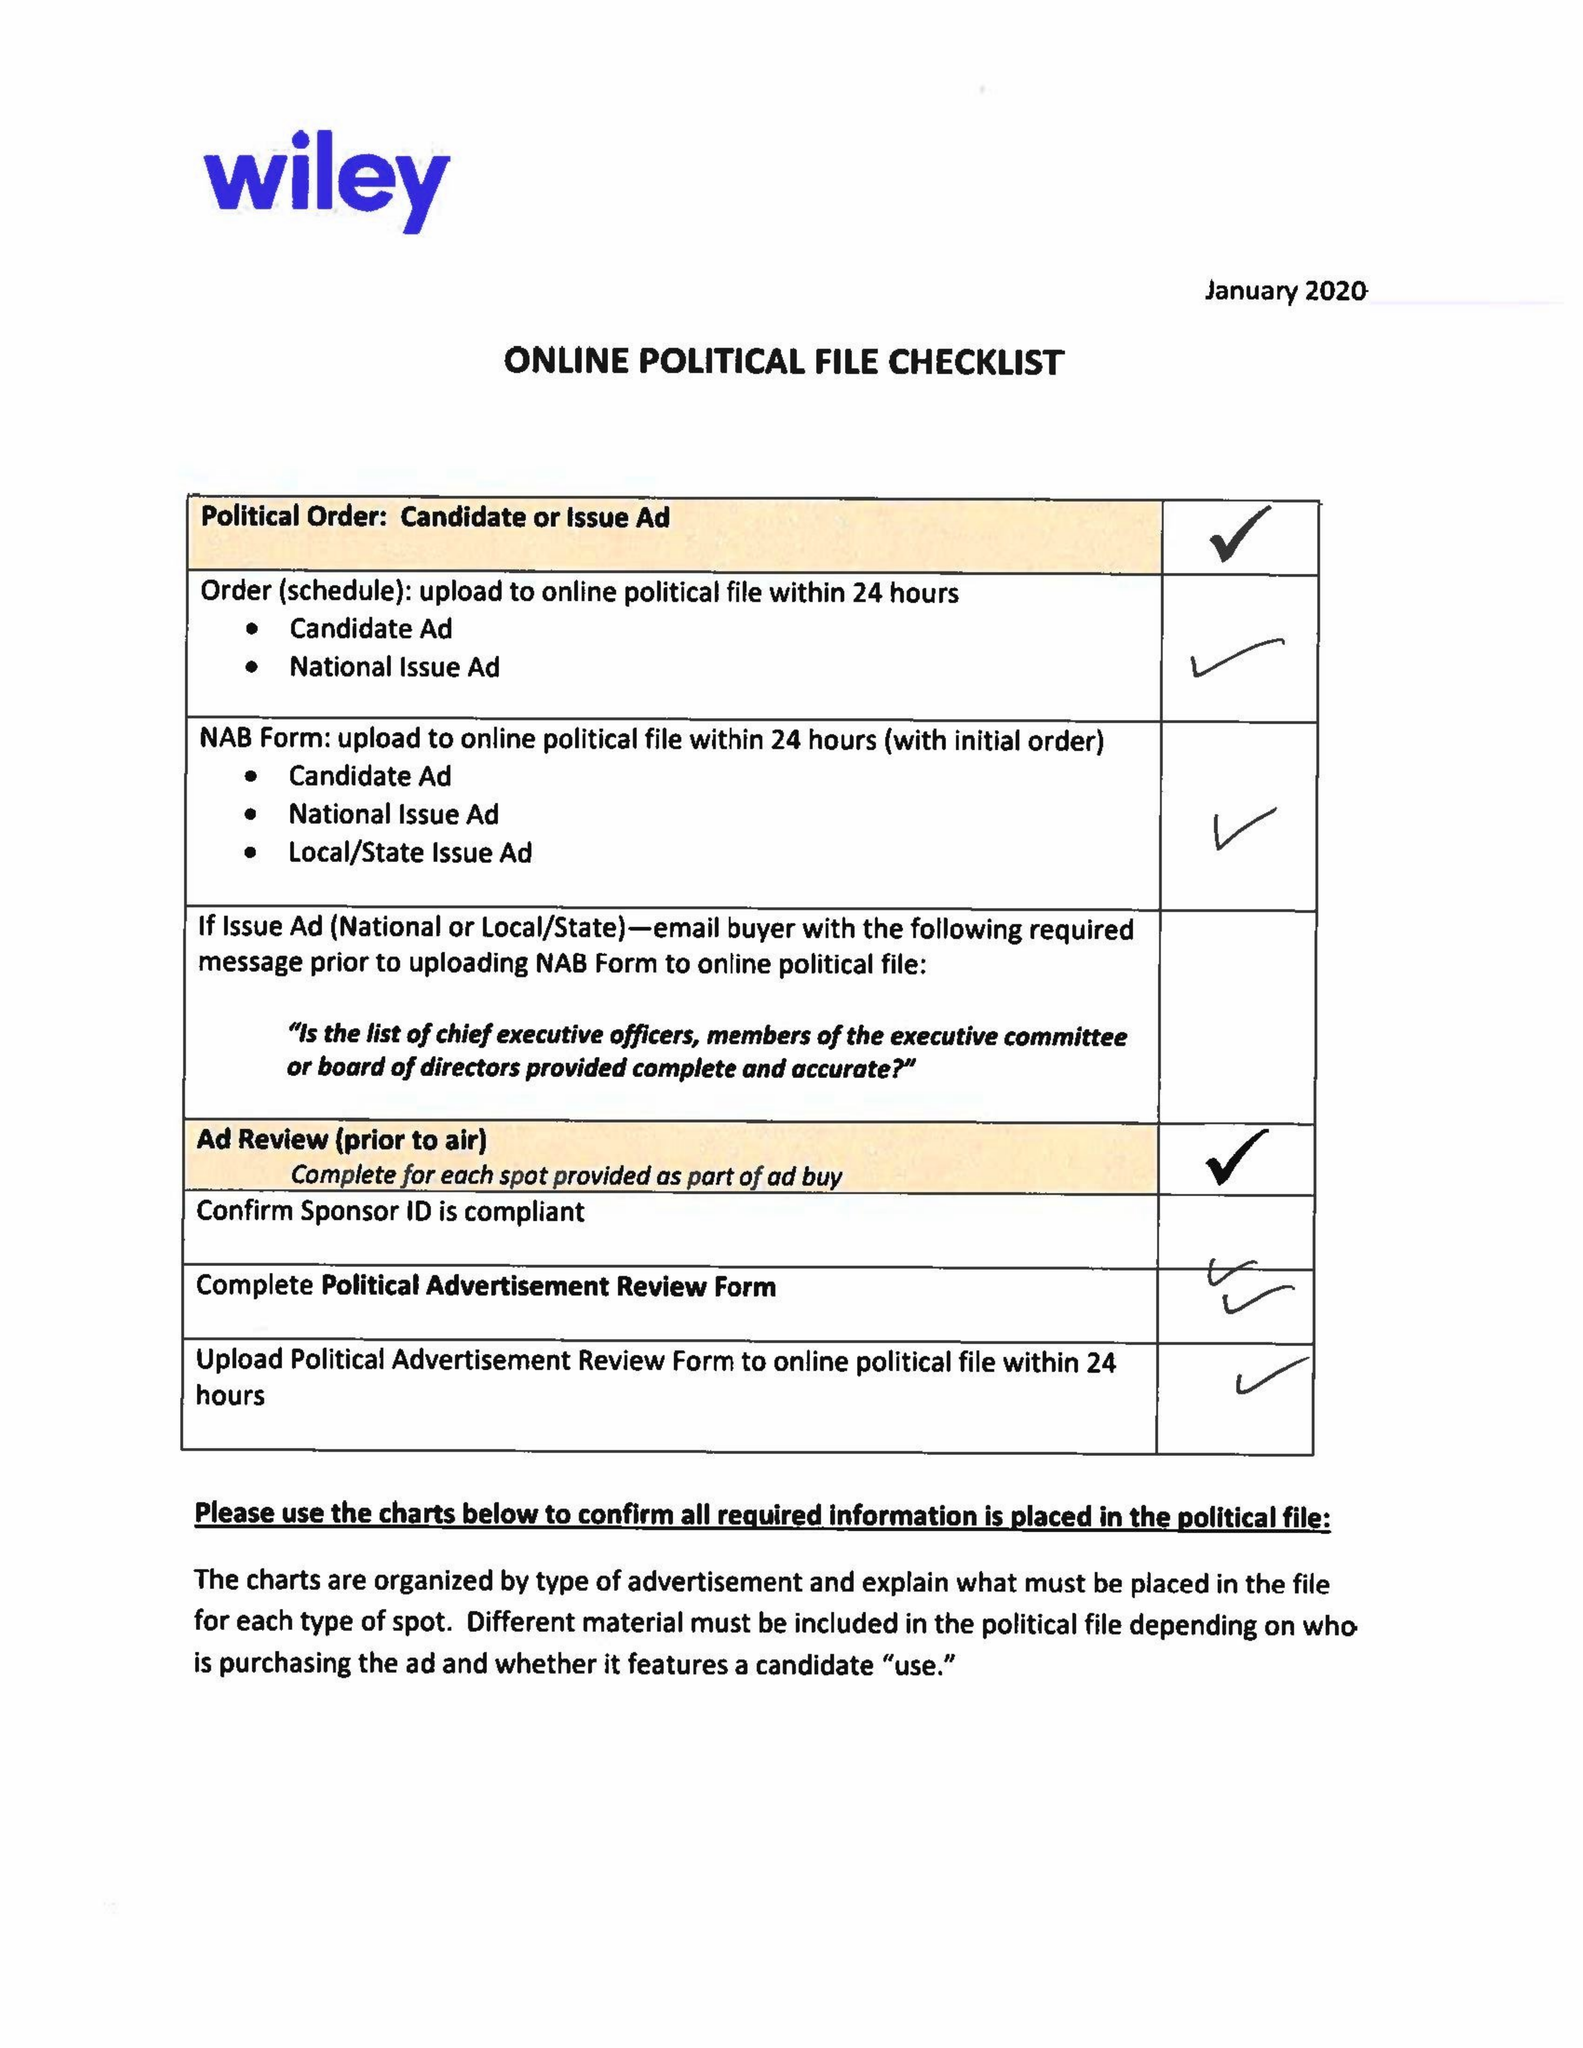What is the value for the gross_amount?
Answer the question using a single word or phrase. 13955.00 